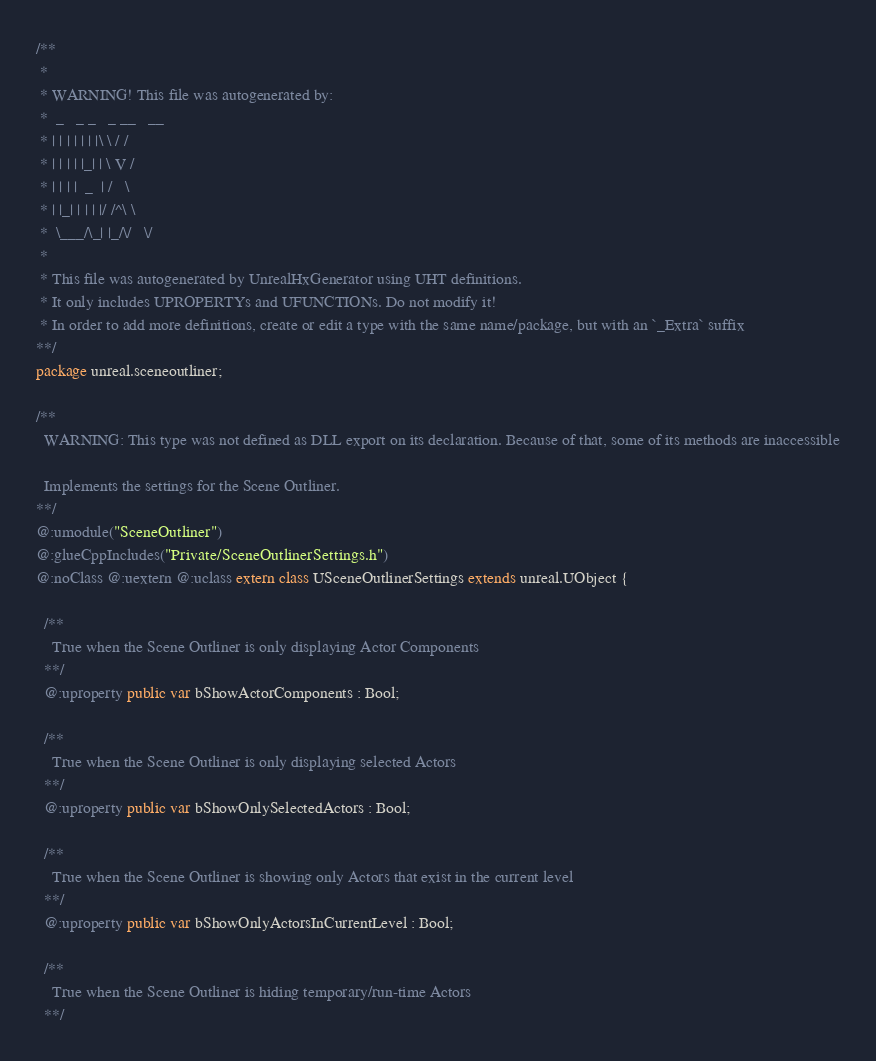<code> <loc_0><loc_0><loc_500><loc_500><_Haxe_>/**
 * 
 * WARNING! This file was autogenerated by: 
 *  _   _ _   _ __   __ 
 * | | | | | | |\ \ / / 
 * | | | | |_| | \ V /  
 * | | | |  _  | /   \  
 * | |_| | | | |/ /^\ \ 
 *  \___/\_| |_/\/   \/ 
 * 
 * This file was autogenerated by UnrealHxGenerator using UHT definitions.
 * It only includes UPROPERTYs and UFUNCTIONs. Do not modify it!
 * In order to add more definitions, create or edit a type with the same name/package, but with an `_Extra` suffix
**/
package unreal.sceneoutliner;

/**
  WARNING: This type was not defined as DLL export on its declaration. Because of that, some of its methods are inaccessible
  
  Implements the settings for the Scene Outliner.
**/
@:umodule("SceneOutliner")
@:glueCppIncludes("Private/SceneOutlinerSettings.h")
@:noClass @:uextern @:uclass extern class USceneOutlinerSettings extends unreal.UObject {
  
  /**
    True when the Scene Outliner is only displaying Actor Components
  **/
  @:uproperty public var bShowActorComponents : Bool;
  
  /**
    True when the Scene Outliner is only displaying selected Actors
  **/
  @:uproperty public var bShowOnlySelectedActors : Bool;
  
  /**
    True when the Scene Outliner is showing only Actors that exist in the current level
  **/
  @:uproperty public var bShowOnlyActorsInCurrentLevel : Bool;
  
  /**
    True when the Scene Outliner is hiding temporary/run-time Actors
  **/</code> 